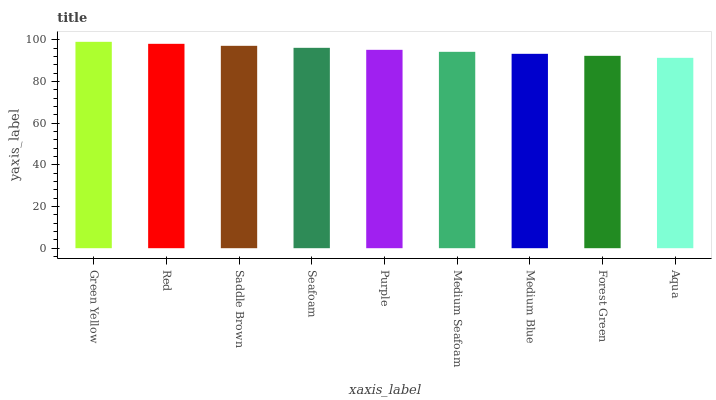Is Aqua the minimum?
Answer yes or no. Yes. Is Green Yellow the maximum?
Answer yes or no. Yes. Is Red the minimum?
Answer yes or no. No. Is Red the maximum?
Answer yes or no. No. Is Green Yellow greater than Red?
Answer yes or no. Yes. Is Red less than Green Yellow?
Answer yes or no. Yes. Is Red greater than Green Yellow?
Answer yes or no. No. Is Green Yellow less than Red?
Answer yes or no. No. Is Purple the high median?
Answer yes or no. Yes. Is Purple the low median?
Answer yes or no. Yes. Is Medium Blue the high median?
Answer yes or no. No. Is Seafoam the low median?
Answer yes or no. No. 